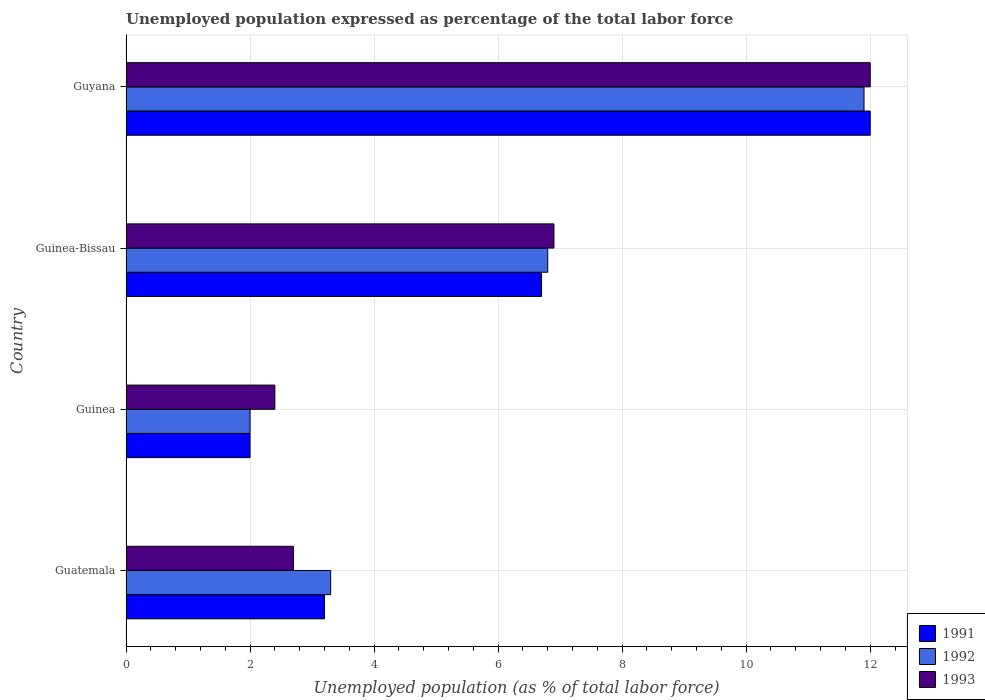How many different coloured bars are there?
Offer a very short reply. 3. How many groups of bars are there?
Offer a terse response. 4. Are the number of bars per tick equal to the number of legend labels?
Your answer should be very brief. Yes. Are the number of bars on each tick of the Y-axis equal?
Your answer should be very brief. Yes. How many bars are there on the 1st tick from the top?
Offer a terse response. 3. How many bars are there on the 4th tick from the bottom?
Keep it short and to the point. 3. What is the label of the 2nd group of bars from the top?
Offer a terse response. Guinea-Bissau. In how many cases, is the number of bars for a given country not equal to the number of legend labels?
Offer a terse response. 0. Across all countries, what is the maximum unemployment in in 1992?
Ensure brevity in your answer.  11.9. Across all countries, what is the minimum unemployment in in 1991?
Your answer should be compact. 2. In which country was the unemployment in in 1991 maximum?
Make the answer very short. Guyana. In which country was the unemployment in in 1993 minimum?
Provide a succinct answer. Guinea. What is the total unemployment in in 1992 in the graph?
Offer a terse response. 24. What is the difference between the unemployment in in 1992 in Guinea-Bissau and that in Guyana?
Your response must be concise. -5.1. What is the difference between the unemployment in in 1992 in Guinea-Bissau and the unemployment in in 1993 in Guinea?
Give a very brief answer. 4.4. What is the average unemployment in in 1992 per country?
Your response must be concise. 6. What is the difference between the unemployment in in 1993 and unemployment in in 1992 in Guinea-Bissau?
Give a very brief answer. 0.1. In how many countries, is the unemployment in in 1992 greater than 11.6 %?
Your answer should be compact. 1. What is the ratio of the unemployment in in 1991 in Guatemala to that in Guyana?
Your answer should be very brief. 0.27. Is the unemployment in in 1991 in Guinea less than that in Guyana?
Make the answer very short. Yes. Is the difference between the unemployment in in 1993 in Guinea-Bissau and Guyana greater than the difference between the unemployment in in 1992 in Guinea-Bissau and Guyana?
Offer a very short reply. No. What is the difference between the highest and the second highest unemployment in in 1993?
Provide a short and direct response. 5.1. In how many countries, is the unemployment in in 1993 greater than the average unemployment in in 1993 taken over all countries?
Offer a very short reply. 2. What does the 1st bar from the bottom in Guyana represents?
Ensure brevity in your answer.  1991. Is it the case that in every country, the sum of the unemployment in in 1991 and unemployment in in 1992 is greater than the unemployment in in 1993?
Make the answer very short. Yes. How many bars are there?
Offer a very short reply. 12. Does the graph contain any zero values?
Provide a succinct answer. No. Does the graph contain grids?
Make the answer very short. Yes. Where does the legend appear in the graph?
Make the answer very short. Bottom right. How many legend labels are there?
Your answer should be compact. 3. What is the title of the graph?
Your answer should be very brief. Unemployed population expressed as percentage of the total labor force. What is the label or title of the X-axis?
Offer a terse response. Unemployed population (as % of total labor force). What is the Unemployed population (as % of total labor force) of 1991 in Guatemala?
Make the answer very short. 3.2. What is the Unemployed population (as % of total labor force) in 1992 in Guatemala?
Give a very brief answer. 3.3. What is the Unemployed population (as % of total labor force) of 1993 in Guatemala?
Ensure brevity in your answer.  2.7. What is the Unemployed population (as % of total labor force) in 1991 in Guinea?
Your response must be concise. 2. What is the Unemployed population (as % of total labor force) in 1993 in Guinea?
Keep it short and to the point. 2.4. What is the Unemployed population (as % of total labor force) in 1991 in Guinea-Bissau?
Your response must be concise. 6.7. What is the Unemployed population (as % of total labor force) in 1992 in Guinea-Bissau?
Give a very brief answer. 6.8. What is the Unemployed population (as % of total labor force) in 1993 in Guinea-Bissau?
Provide a short and direct response. 6.9. What is the Unemployed population (as % of total labor force) in 1991 in Guyana?
Offer a terse response. 12. What is the Unemployed population (as % of total labor force) in 1992 in Guyana?
Ensure brevity in your answer.  11.9. What is the Unemployed population (as % of total labor force) of 1993 in Guyana?
Offer a terse response. 12. Across all countries, what is the maximum Unemployed population (as % of total labor force) of 1991?
Provide a succinct answer. 12. Across all countries, what is the maximum Unemployed population (as % of total labor force) of 1992?
Give a very brief answer. 11.9. Across all countries, what is the maximum Unemployed population (as % of total labor force) of 1993?
Make the answer very short. 12. Across all countries, what is the minimum Unemployed population (as % of total labor force) in 1991?
Ensure brevity in your answer.  2. Across all countries, what is the minimum Unemployed population (as % of total labor force) of 1993?
Offer a very short reply. 2.4. What is the total Unemployed population (as % of total labor force) in 1991 in the graph?
Your answer should be compact. 23.9. What is the total Unemployed population (as % of total labor force) in 1992 in the graph?
Your answer should be compact. 24. What is the difference between the Unemployed population (as % of total labor force) in 1992 in Guatemala and that in Guinea?
Offer a terse response. 1.3. What is the difference between the Unemployed population (as % of total labor force) of 1993 in Guatemala and that in Guinea?
Offer a terse response. 0.3. What is the difference between the Unemployed population (as % of total labor force) in 1992 in Guatemala and that in Guinea-Bissau?
Your answer should be compact. -3.5. What is the difference between the Unemployed population (as % of total labor force) of 1993 in Guatemala and that in Guinea-Bissau?
Make the answer very short. -4.2. What is the difference between the Unemployed population (as % of total labor force) of 1991 in Guinea and that in Guinea-Bissau?
Give a very brief answer. -4.7. What is the difference between the Unemployed population (as % of total labor force) in 1992 in Guinea and that in Guinea-Bissau?
Keep it short and to the point. -4.8. What is the difference between the Unemployed population (as % of total labor force) of 1991 in Guinea and that in Guyana?
Keep it short and to the point. -10. What is the difference between the Unemployed population (as % of total labor force) in 1992 in Guinea and that in Guyana?
Your answer should be very brief. -9.9. What is the difference between the Unemployed population (as % of total labor force) in 1993 in Guinea and that in Guyana?
Offer a very short reply. -9.6. What is the difference between the Unemployed population (as % of total labor force) of 1993 in Guinea-Bissau and that in Guyana?
Give a very brief answer. -5.1. What is the difference between the Unemployed population (as % of total labor force) of 1992 in Guatemala and the Unemployed population (as % of total labor force) of 1993 in Guinea?
Provide a short and direct response. 0.9. What is the difference between the Unemployed population (as % of total labor force) in 1991 in Guatemala and the Unemployed population (as % of total labor force) in 1992 in Guinea-Bissau?
Keep it short and to the point. -3.6. What is the difference between the Unemployed population (as % of total labor force) in 1992 in Guatemala and the Unemployed population (as % of total labor force) in 1993 in Guinea-Bissau?
Keep it short and to the point. -3.6. What is the difference between the Unemployed population (as % of total labor force) of 1991 in Guatemala and the Unemployed population (as % of total labor force) of 1992 in Guyana?
Your response must be concise. -8.7. What is the difference between the Unemployed population (as % of total labor force) of 1991 in Guatemala and the Unemployed population (as % of total labor force) of 1993 in Guyana?
Provide a short and direct response. -8.8. What is the difference between the Unemployed population (as % of total labor force) of 1992 in Guatemala and the Unemployed population (as % of total labor force) of 1993 in Guyana?
Provide a succinct answer. -8.7. What is the difference between the Unemployed population (as % of total labor force) in 1991 in Guinea and the Unemployed population (as % of total labor force) in 1992 in Guyana?
Your answer should be very brief. -9.9. What is the difference between the Unemployed population (as % of total labor force) of 1991 in Guinea and the Unemployed population (as % of total labor force) of 1993 in Guyana?
Your answer should be compact. -10. What is the difference between the Unemployed population (as % of total labor force) in 1992 in Guinea and the Unemployed population (as % of total labor force) in 1993 in Guyana?
Offer a very short reply. -10. What is the average Unemployed population (as % of total labor force) of 1991 per country?
Give a very brief answer. 5.97. What is the difference between the Unemployed population (as % of total labor force) of 1992 and Unemployed population (as % of total labor force) of 1993 in Guatemala?
Your response must be concise. 0.6. What is the difference between the Unemployed population (as % of total labor force) in 1991 and Unemployed population (as % of total labor force) in 1992 in Guinea?
Provide a succinct answer. 0. What is the difference between the Unemployed population (as % of total labor force) of 1991 and Unemployed population (as % of total labor force) of 1993 in Guinea?
Give a very brief answer. -0.4. What is the difference between the Unemployed population (as % of total labor force) of 1992 and Unemployed population (as % of total labor force) of 1993 in Guinea?
Your answer should be very brief. -0.4. What is the difference between the Unemployed population (as % of total labor force) in 1991 and Unemployed population (as % of total labor force) in 1992 in Guinea-Bissau?
Your answer should be compact. -0.1. What is the difference between the Unemployed population (as % of total labor force) in 1991 and Unemployed population (as % of total labor force) in 1992 in Guyana?
Give a very brief answer. 0.1. What is the difference between the Unemployed population (as % of total labor force) of 1992 and Unemployed population (as % of total labor force) of 1993 in Guyana?
Give a very brief answer. -0.1. What is the ratio of the Unemployed population (as % of total labor force) in 1992 in Guatemala to that in Guinea?
Provide a short and direct response. 1.65. What is the ratio of the Unemployed population (as % of total labor force) in 1991 in Guatemala to that in Guinea-Bissau?
Provide a succinct answer. 0.48. What is the ratio of the Unemployed population (as % of total labor force) of 1992 in Guatemala to that in Guinea-Bissau?
Keep it short and to the point. 0.49. What is the ratio of the Unemployed population (as % of total labor force) in 1993 in Guatemala to that in Guinea-Bissau?
Your answer should be compact. 0.39. What is the ratio of the Unemployed population (as % of total labor force) of 1991 in Guatemala to that in Guyana?
Give a very brief answer. 0.27. What is the ratio of the Unemployed population (as % of total labor force) in 1992 in Guatemala to that in Guyana?
Keep it short and to the point. 0.28. What is the ratio of the Unemployed population (as % of total labor force) of 1993 in Guatemala to that in Guyana?
Make the answer very short. 0.23. What is the ratio of the Unemployed population (as % of total labor force) in 1991 in Guinea to that in Guinea-Bissau?
Make the answer very short. 0.3. What is the ratio of the Unemployed population (as % of total labor force) of 1992 in Guinea to that in Guinea-Bissau?
Provide a succinct answer. 0.29. What is the ratio of the Unemployed population (as % of total labor force) of 1993 in Guinea to that in Guinea-Bissau?
Offer a terse response. 0.35. What is the ratio of the Unemployed population (as % of total labor force) of 1991 in Guinea to that in Guyana?
Your answer should be compact. 0.17. What is the ratio of the Unemployed population (as % of total labor force) of 1992 in Guinea to that in Guyana?
Offer a very short reply. 0.17. What is the ratio of the Unemployed population (as % of total labor force) in 1991 in Guinea-Bissau to that in Guyana?
Provide a short and direct response. 0.56. What is the ratio of the Unemployed population (as % of total labor force) of 1993 in Guinea-Bissau to that in Guyana?
Your answer should be compact. 0.57. What is the difference between the highest and the lowest Unemployed population (as % of total labor force) of 1992?
Your answer should be very brief. 9.9. 